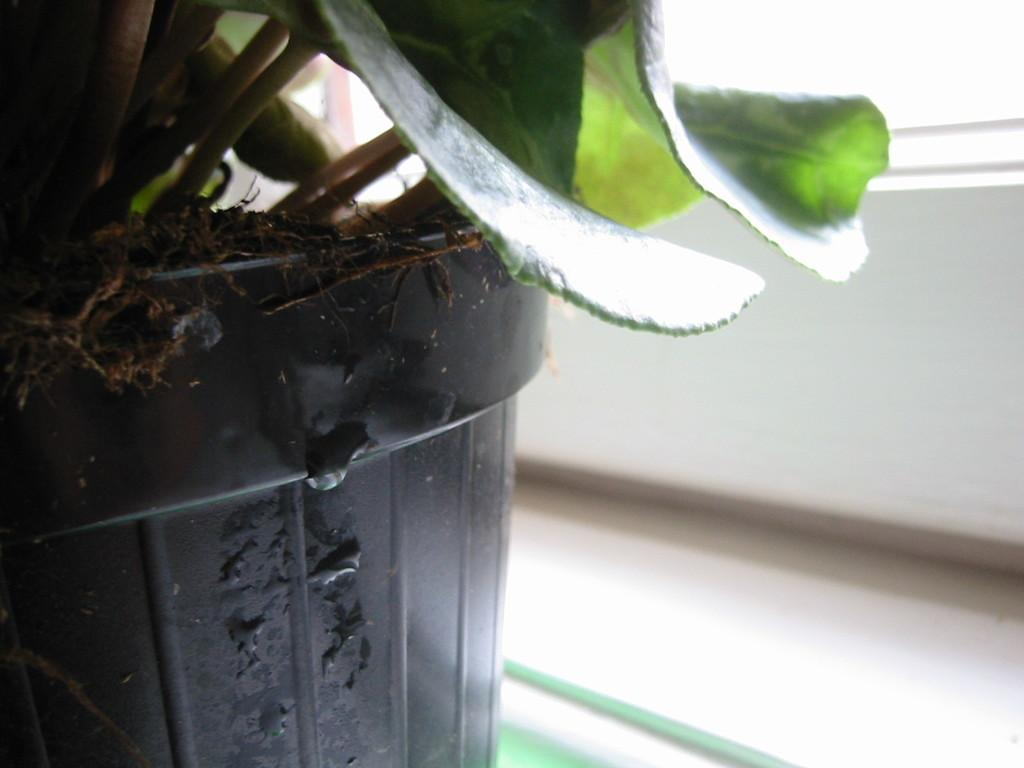What type of plant is visible in the image? There is a plant with leaves in the image. How is the plant contained or supported? The plant is placed in a pot. Where is the pot located in the image? The pot is kept on a surface. What activity is the plant participating in within the image? Plants do not participate in activities; they are living organisms that grow and produce leaves. 